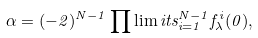Convert formula to latex. <formula><loc_0><loc_0><loc_500><loc_500>\alpha = ( - 2 ) ^ { N - 1 } \prod \lim i t s _ { i = 1 } ^ { N - 1 } f ^ { i } _ { \lambda } ( 0 ) ,</formula> 